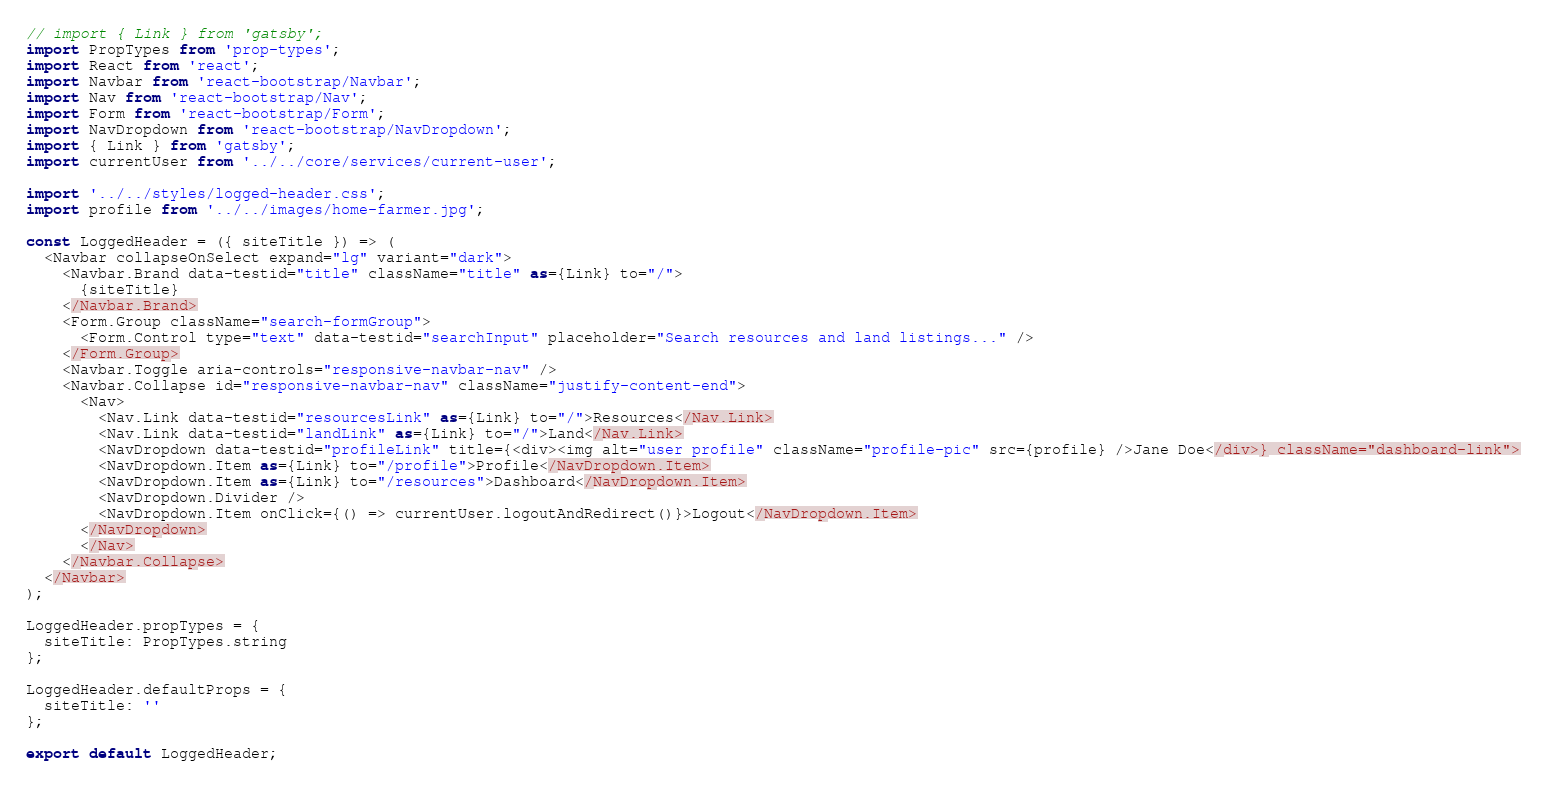<code> <loc_0><loc_0><loc_500><loc_500><_JavaScript_>// import { Link } from 'gatsby';
import PropTypes from 'prop-types';
import React from 'react';
import Navbar from 'react-bootstrap/Navbar';
import Nav from 'react-bootstrap/Nav';
import Form from 'react-bootstrap/Form';
import NavDropdown from 'react-bootstrap/NavDropdown';
import { Link } from 'gatsby';
import currentUser from '../../core/services/current-user';

import '../../styles/logged-header.css';
import profile from '../../images/home-farmer.jpg';

const LoggedHeader = ({ siteTitle }) => (
  <Navbar collapseOnSelect expand="lg" variant="dark">
    <Navbar.Brand data-testid="title" className="title" as={Link} to="/">
      {siteTitle}
    </Navbar.Brand>
    <Form.Group className="search-formGroup">
      <Form.Control type="text" data-testid="searchInput" placeholder="Search resources and land listings..." />
    </Form.Group>
    <Navbar.Toggle aria-controls="responsive-navbar-nav" />
    <Navbar.Collapse id="responsive-navbar-nav" className="justify-content-end">
      <Nav>
        <Nav.Link data-testid="resourcesLink" as={Link} to="/">Resources</Nav.Link>
        <Nav.Link data-testid="landLink" as={Link} to="/">Land</Nav.Link>
        <NavDropdown data-testid="profileLink" title={<div><img alt="user profile" className="profile-pic" src={profile} />Jane Doe</div>} className="dashboard-link">
        <NavDropdown.Item as={Link} to="/profile">Profile</NavDropdown.Item>
        <NavDropdown.Item as={Link} to="/resources">Dashboard</NavDropdown.Item>
        <NavDropdown.Divider />
        <NavDropdown.Item onClick={() => currentUser.logoutAndRedirect()}>Logout</NavDropdown.Item>
      </NavDropdown>
      </Nav>
    </Navbar.Collapse>
  </Navbar>
);

LoggedHeader.propTypes = {
  siteTitle: PropTypes.string
};

LoggedHeader.defaultProps = {
  siteTitle: ''
};

export default LoggedHeader;
</code> 